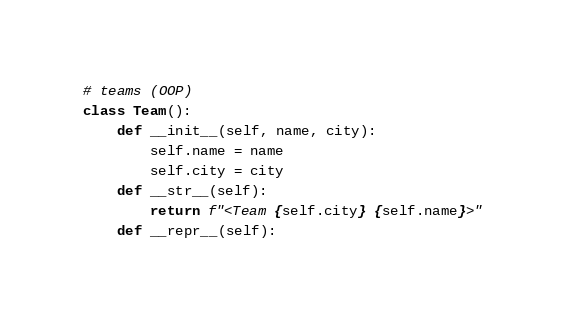Convert code to text. <code><loc_0><loc_0><loc_500><loc_500><_Python_>

# teams (OOP)
class Team():
    def __init__(self, name, city):
        self.name = name
        self.city = city
    def __str__(self):
        return f"<Team {self.city} {self.name}>"
    def __repr__(self):</code> 